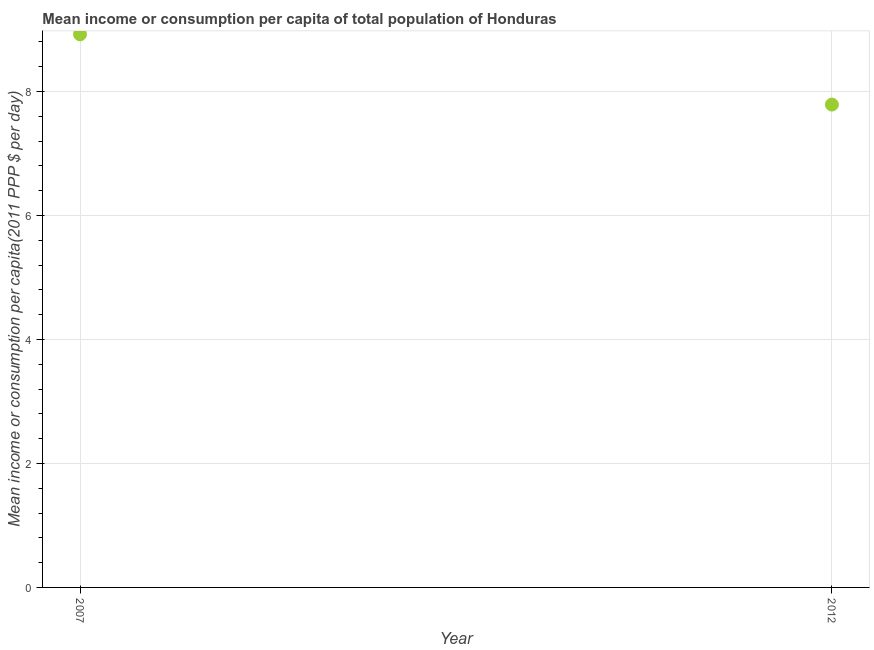What is the mean income or consumption in 2007?
Give a very brief answer. 8.92. Across all years, what is the maximum mean income or consumption?
Your answer should be very brief. 8.92. Across all years, what is the minimum mean income or consumption?
Keep it short and to the point. 7.79. What is the sum of the mean income or consumption?
Provide a short and direct response. 16.71. What is the difference between the mean income or consumption in 2007 and 2012?
Provide a short and direct response. 1.13. What is the average mean income or consumption per year?
Make the answer very short. 8.36. What is the median mean income or consumption?
Your response must be concise. 8.36. In how many years, is the mean income or consumption greater than 4.4 $?
Your response must be concise. 2. What is the ratio of the mean income or consumption in 2007 to that in 2012?
Provide a short and direct response. 1.15. In how many years, is the mean income or consumption greater than the average mean income or consumption taken over all years?
Your answer should be compact. 1. Does the mean income or consumption monotonically increase over the years?
Ensure brevity in your answer.  No. How many years are there in the graph?
Offer a very short reply. 2. What is the difference between two consecutive major ticks on the Y-axis?
Ensure brevity in your answer.  2. Does the graph contain any zero values?
Your answer should be very brief. No. What is the title of the graph?
Your answer should be compact. Mean income or consumption per capita of total population of Honduras. What is the label or title of the X-axis?
Your answer should be compact. Year. What is the label or title of the Y-axis?
Offer a terse response. Mean income or consumption per capita(2011 PPP $ per day). What is the Mean income or consumption per capita(2011 PPP $ per day) in 2007?
Ensure brevity in your answer.  8.92. What is the Mean income or consumption per capita(2011 PPP $ per day) in 2012?
Give a very brief answer. 7.79. What is the difference between the Mean income or consumption per capita(2011 PPP $ per day) in 2007 and 2012?
Offer a terse response. 1.13. What is the ratio of the Mean income or consumption per capita(2011 PPP $ per day) in 2007 to that in 2012?
Make the answer very short. 1.15. 